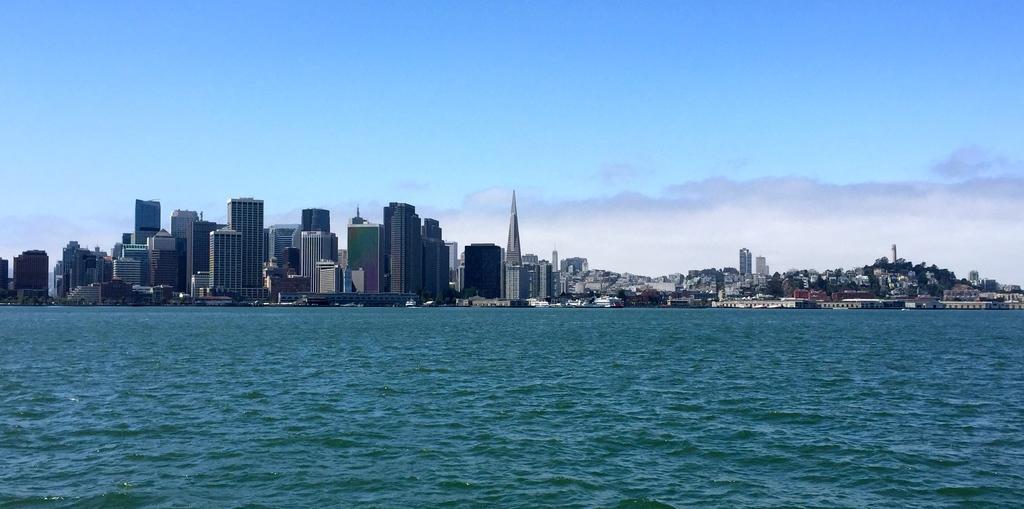Describe this image in one or two sentences. In the picture I can see water and there are buildings in the background. 